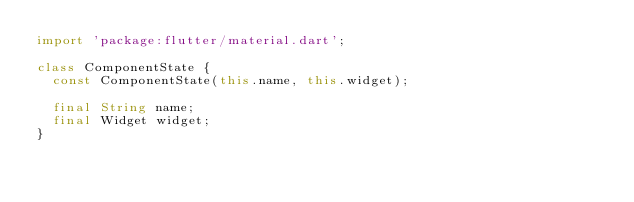<code> <loc_0><loc_0><loc_500><loc_500><_Dart_>import 'package:flutter/material.dart';

class ComponentState {
  const ComponentState(this.name, this.widget);

  final String name;
  final Widget widget;
}
</code> 